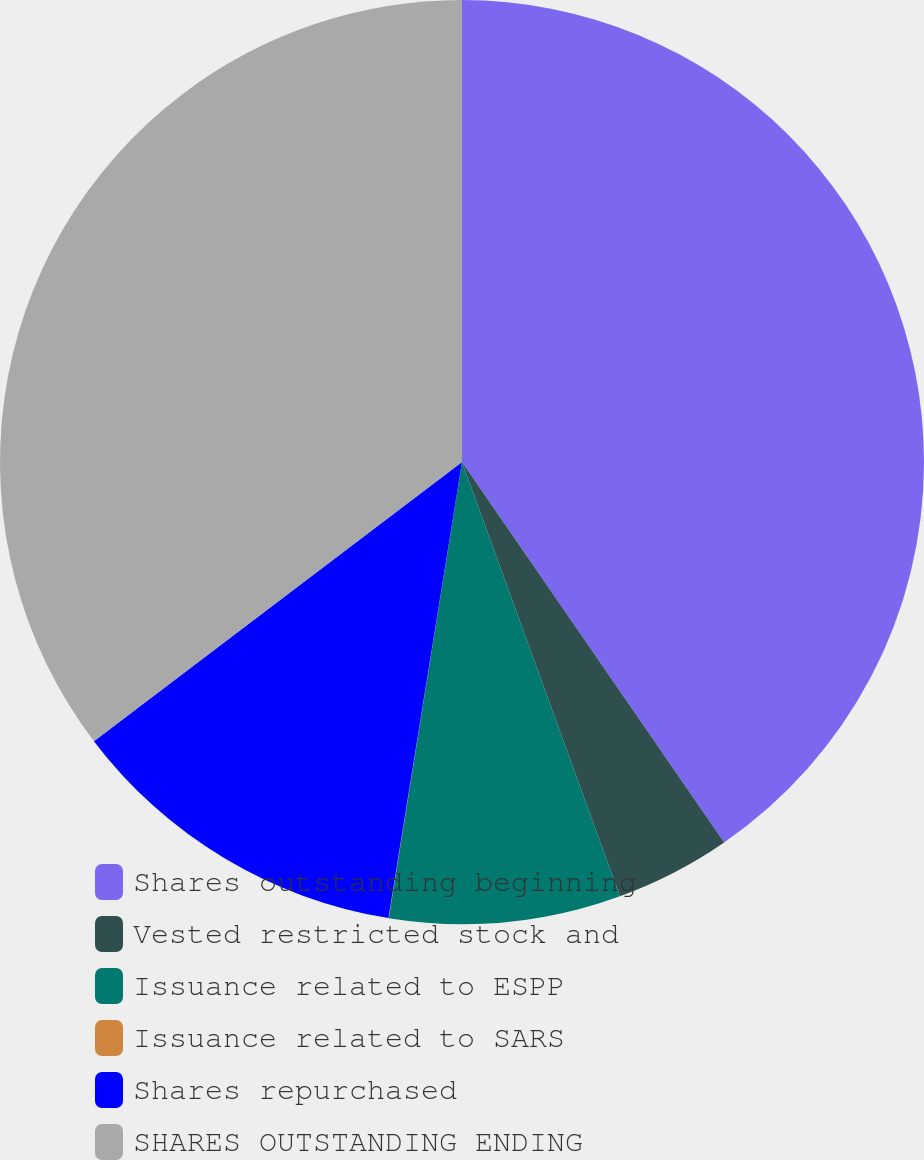<chart> <loc_0><loc_0><loc_500><loc_500><pie_chart><fcel>Shares outstanding beginning<fcel>Vested restricted stock and<fcel>Issuance related to ESPP<fcel>Issuance related to SARS<fcel>Shares repurchased<fcel>SHARES OUTSTANDING ENDING<nl><fcel>40.4%<fcel>4.05%<fcel>8.09%<fcel>0.01%<fcel>12.13%<fcel>35.33%<nl></chart> 